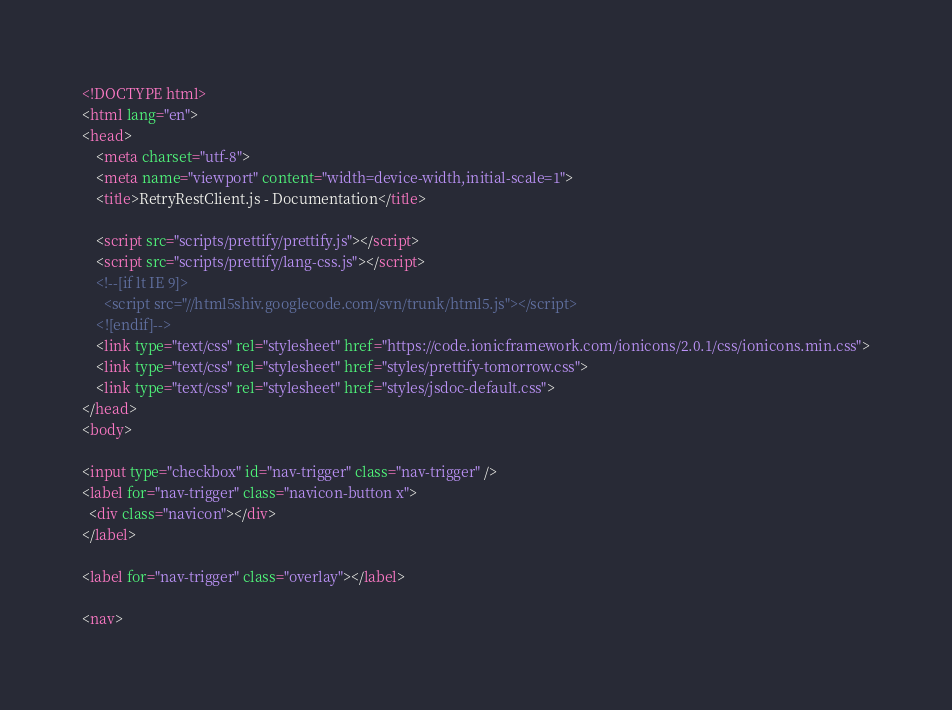<code> <loc_0><loc_0><loc_500><loc_500><_HTML_><!DOCTYPE html>
<html lang="en">
<head>
    <meta charset="utf-8">
    <meta name="viewport" content="width=device-width,initial-scale=1">
    <title>RetryRestClient.js - Documentation</title>

    <script src="scripts/prettify/prettify.js"></script>
    <script src="scripts/prettify/lang-css.js"></script>
    <!--[if lt IE 9]>
      <script src="//html5shiv.googlecode.com/svn/trunk/html5.js"></script>
    <![endif]-->
    <link type="text/css" rel="stylesheet" href="https://code.ionicframework.com/ionicons/2.0.1/css/ionicons.min.css">
    <link type="text/css" rel="stylesheet" href="styles/prettify-tomorrow.css">
    <link type="text/css" rel="stylesheet" href="styles/jsdoc-default.css">
</head>
<body>

<input type="checkbox" id="nav-trigger" class="nav-trigger" />
<label for="nav-trigger" class="navicon-button x">
  <div class="navicon"></div>
</label>

<label for="nav-trigger" class="overlay"></label>

<nav></code> 